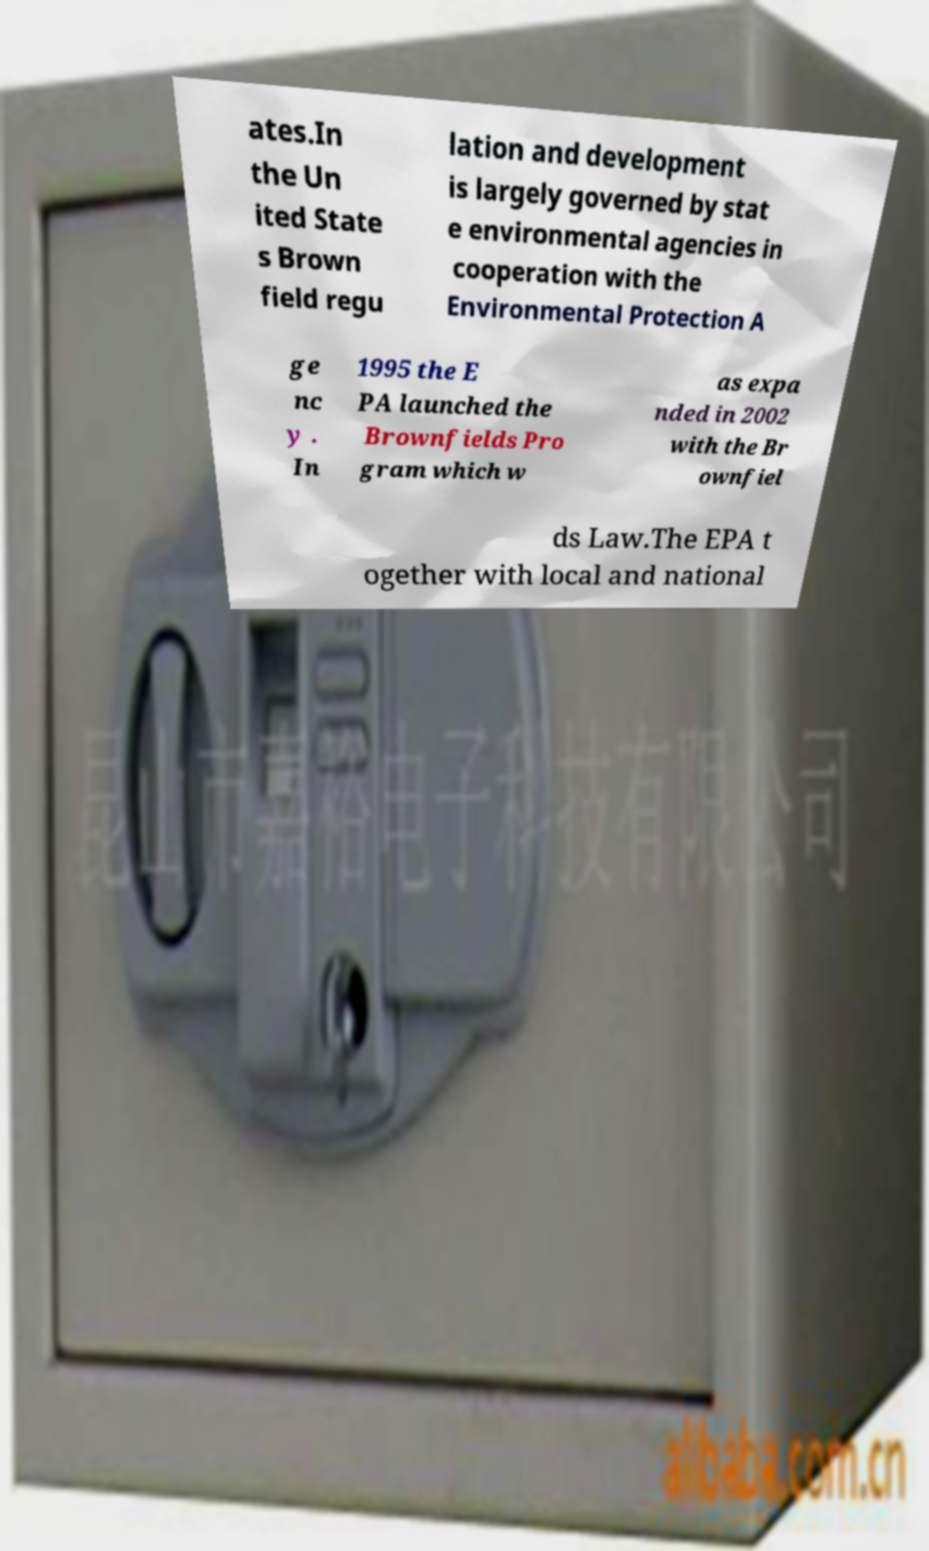I need the written content from this picture converted into text. Can you do that? ates.In the Un ited State s Brown field regu lation and development is largely governed by stat e environmental agencies in cooperation with the Environmental Protection A ge nc y . In 1995 the E PA launched the Brownfields Pro gram which w as expa nded in 2002 with the Br ownfiel ds Law.The EPA t ogether with local and national 